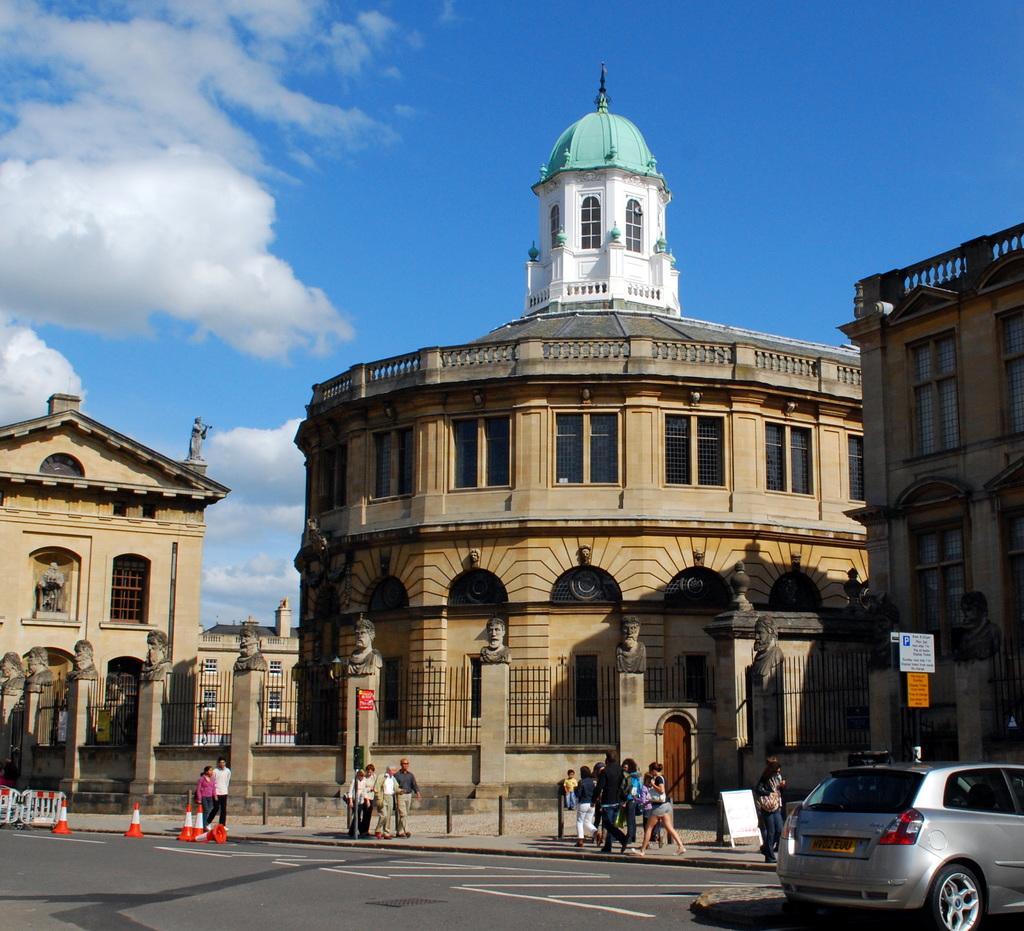How would you summarize this image in a sentence or two? In this picture I can see there is a car on to right side and there are few people walking on the walk way. There are few buildings in the backdrop and it has few windows, there are few pillars and there are statues on the pillars and the sky is clear. 